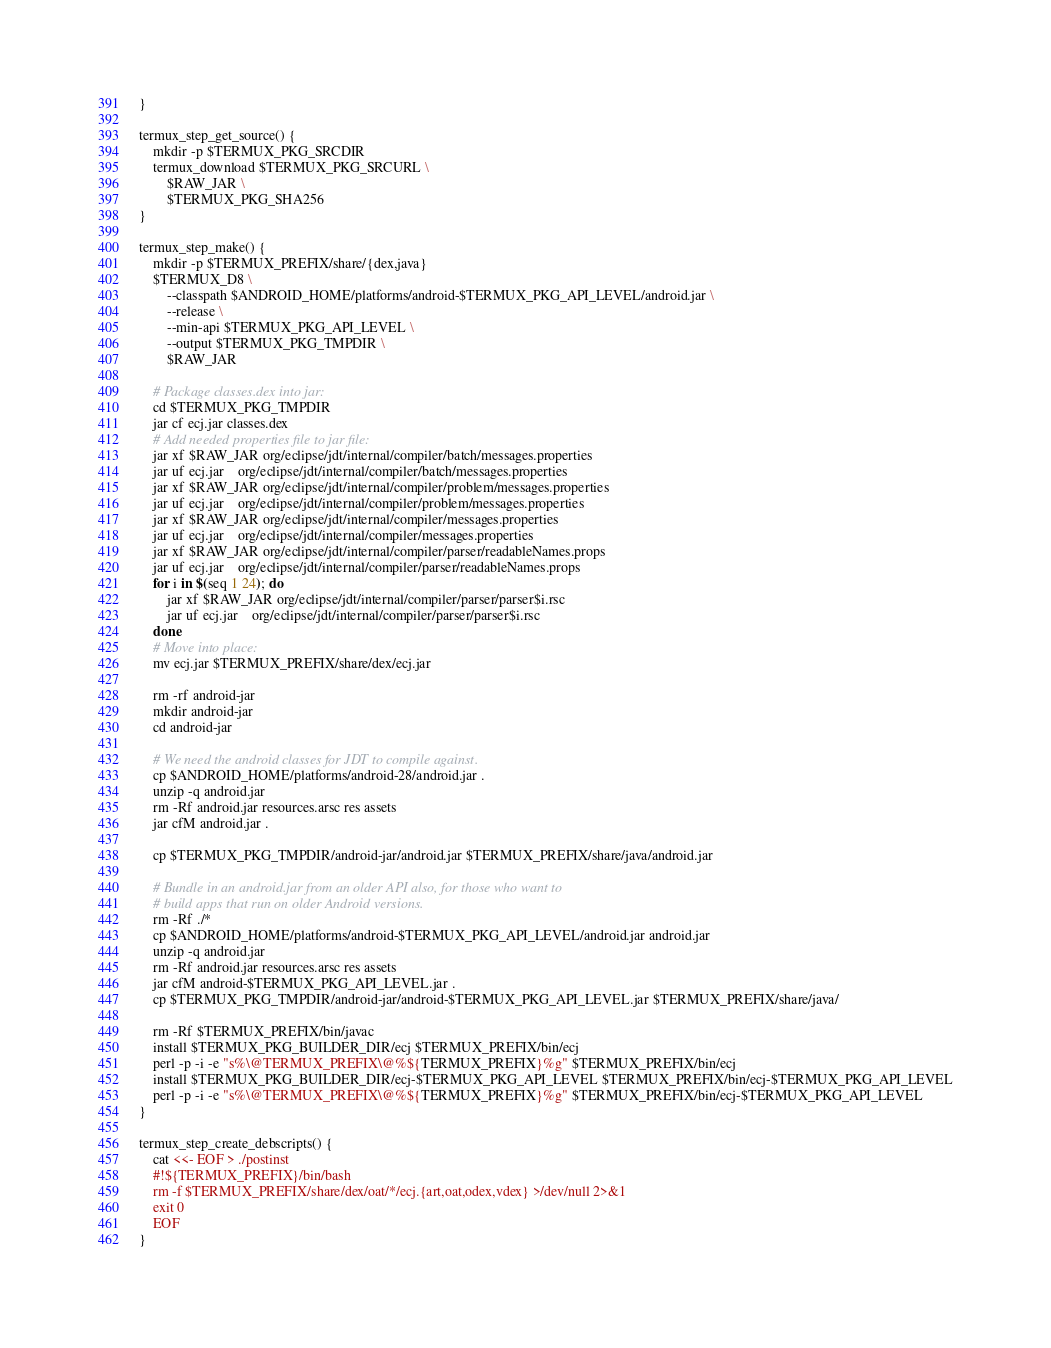Convert code to text. <code><loc_0><loc_0><loc_500><loc_500><_Bash_>}

termux_step_get_source() {
	mkdir -p $TERMUX_PKG_SRCDIR
	termux_download $TERMUX_PKG_SRCURL \
		$RAW_JAR \
		$TERMUX_PKG_SHA256
}

termux_step_make() {
	mkdir -p $TERMUX_PREFIX/share/{dex,java}
	$TERMUX_D8 \
		--classpath $ANDROID_HOME/platforms/android-$TERMUX_PKG_API_LEVEL/android.jar \
		--release \
		--min-api $TERMUX_PKG_API_LEVEL \
		--output $TERMUX_PKG_TMPDIR \
		$RAW_JAR

	# Package classes.dex into jar:
	cd $TERMUX_PKG_TMPDIR
	jar cf ecj.jar classes.dex
	# Add needed properties file to jar file:
	jar xf $RAW_JAR org/eclipse/jdt/internal/compiler/batch/messages.properties
	jar uf ecj.jar	org/eclipse/jdt/internal/compiler/batch/messages.properties
	jar xf $RAW_JAR org/eclipse/jdt/internal/compiler/problem/messages.properties
	jar uf ecj.jar	org/eclipse/jdt/internal/compiler/problem/messages.properties
	jar xf $RAW_JAR org/eclipse/jdt/internal/compiler/messages.properties
	jar uf ecj.jar	org/eclipse/jdt/internal/compiler/messages.properties
	jar xf $RAW_JAR org/eclipse/jdt/internal/compiler/parser/readableNames.props
	jar uf ecj.jar	org/eclipse/jdt/internal/compiler/parser/readableNames.props
	for i in $(seq 1 24); do
		jar xf $RAW_JAR org/eclipse/jdt/internal/compiler/parser/parser$i.rsc
		jar uf ecj.jar	org/eclipse/jdt/internal/compiler/parser/parser$i.rsc
	done
	# Move into place:
	mv ecj.jar $TERMUX_PREFIX/share/dex/ecj.jar

	rm -rf android-jar
	mkdir android-jar
	cd android-jar

	# We need the android classes for JDT to compile against.
	cp $ANDROID_HOME/platforms/android-28/android.jar .
	unzip -q android.jar
	rm -Rf android.jar resources.arsc res assets
	jar cfM android.jar .

	cp $TERMUX_PKG_TMPDIR/android-jar/android.jar $TERMUX_PREFIX/share/java/android.jar

	# Bundle in an android.jar from an older API also, for those who want to
	# build apps that run on older Android versions.
	rm -Rf ./*
	cp $ANDROID_HOME/platforms/android-$TERMUX_PKG_API_LEVEL/android.jar android.jar
	unzip -q android.jar
	rm -Rf android.jar resources.arsc res assets
	jar cfM android-$TERMUX_PKG_API_LEVEL.jar .
	cp $TERMUX_PKG_TMPDIR/android-jar/android-$TERMUX_PKG_API_LEVEL.jar $TERMUX_PREFIX/share/java/

	rm -Rf $TERMUX_PREFIX/bin/javac
	install $TERMUX_PKG_BUILDER_DIR/ecj $TERMUX_PREFIX/bin/ecj
	perl -p -i -e "s%\@TERMUX_PREFIX\@%${TERMUX_PREFIX}%g" $TERMUX_PREFIX/bin/ecj
	install $TERMUX_PKG_BUILDER_DIR/ecj-$TERMUX_PKG_API_LEVEL $TERMUX_PREFIX/bin/ecj-$TERMUX_PKG_API_LEVEL
	perl -p -i -e "s%\@TERMUX_PREFIX\@%${TERMUX_PREFIX}%g" $TERMUX_PREFIX/bin/ecj-$TERMUX_PKG_API_LEVEL
}

termux_step_create_debscripts() {
	cat <<- EOF > ./postinst
	#!${TERMUX_PREFIX}/bin/bash
	rm -f $TERMUX_PREFIX/share/dex/oat/*/ecj.{art,oat,odex,vdex} >/dev/null 2>&1
	exit 0
	EOF
}

</code> 